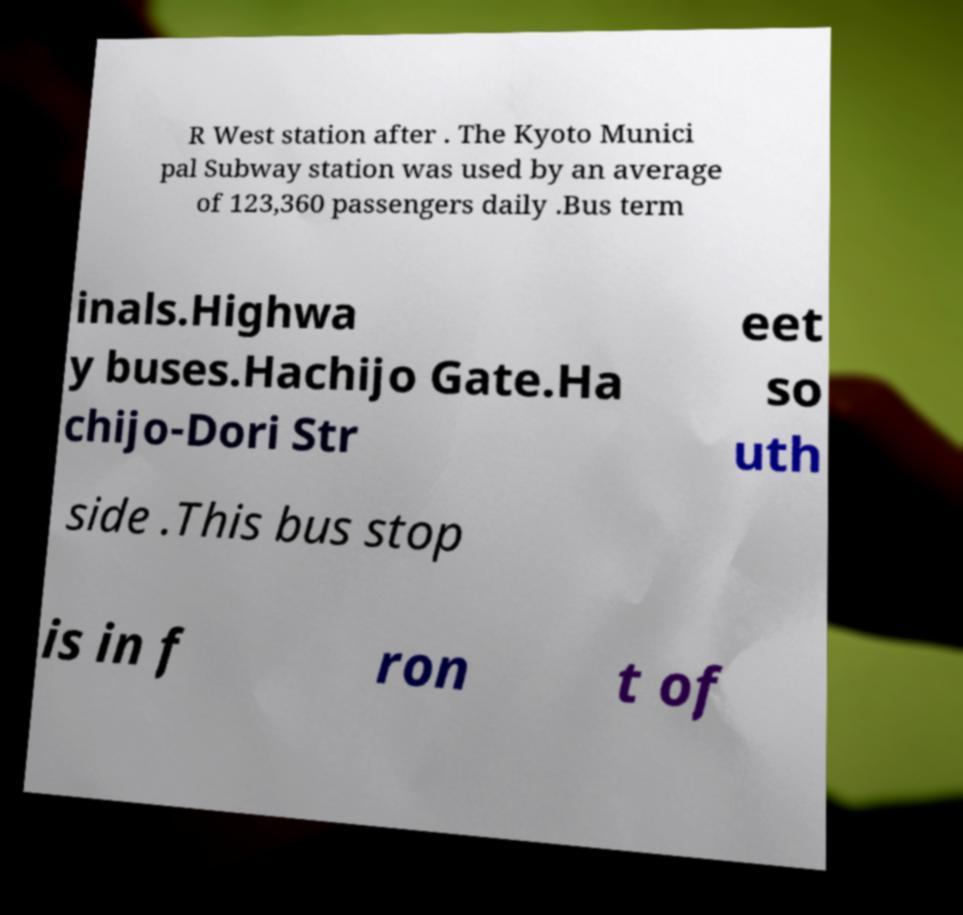For documentation purposes, I need the text within this image transcribed. Could you provide that? R West station after . The Kyoto Munici pal Subway station was used by an average of 123,360 passengers daily .Bus term inals.Highwa y buses.Hachijo Gate.Ha chijo-Dori Str eet so uth side .This bus stop is in f ron t of 